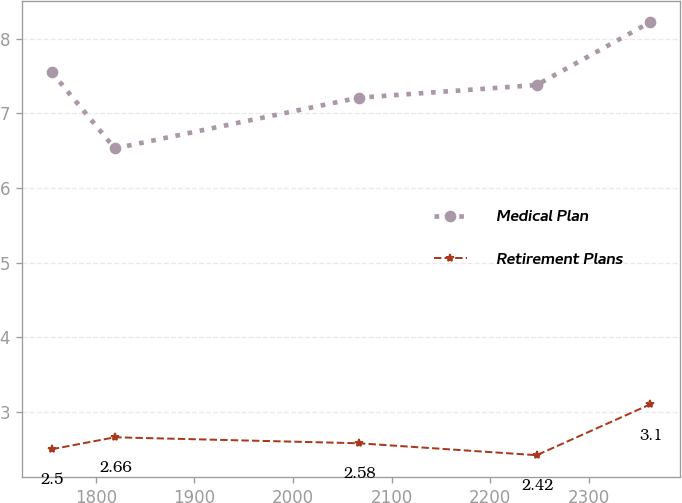Convert chart. <chart><loc_0><loc_0><loc_500><loc_500><line_chart><ecel><fcel>Medical Plan<fcel>Retirement Plans<nl><fcel>1755.41<fcel>7.55<fcel>2.5<nl><fcel>1819.29<fcel>6.53<fcel>2.66<nl><fcel>2066.45<fcel>7.21<fcel>2.58<nl><fcel>2246.95<fcel>7.38<fcel>2.42<nl><fcel>2361.91<fcel>8.22<fcel>3.1<nl></chart> 